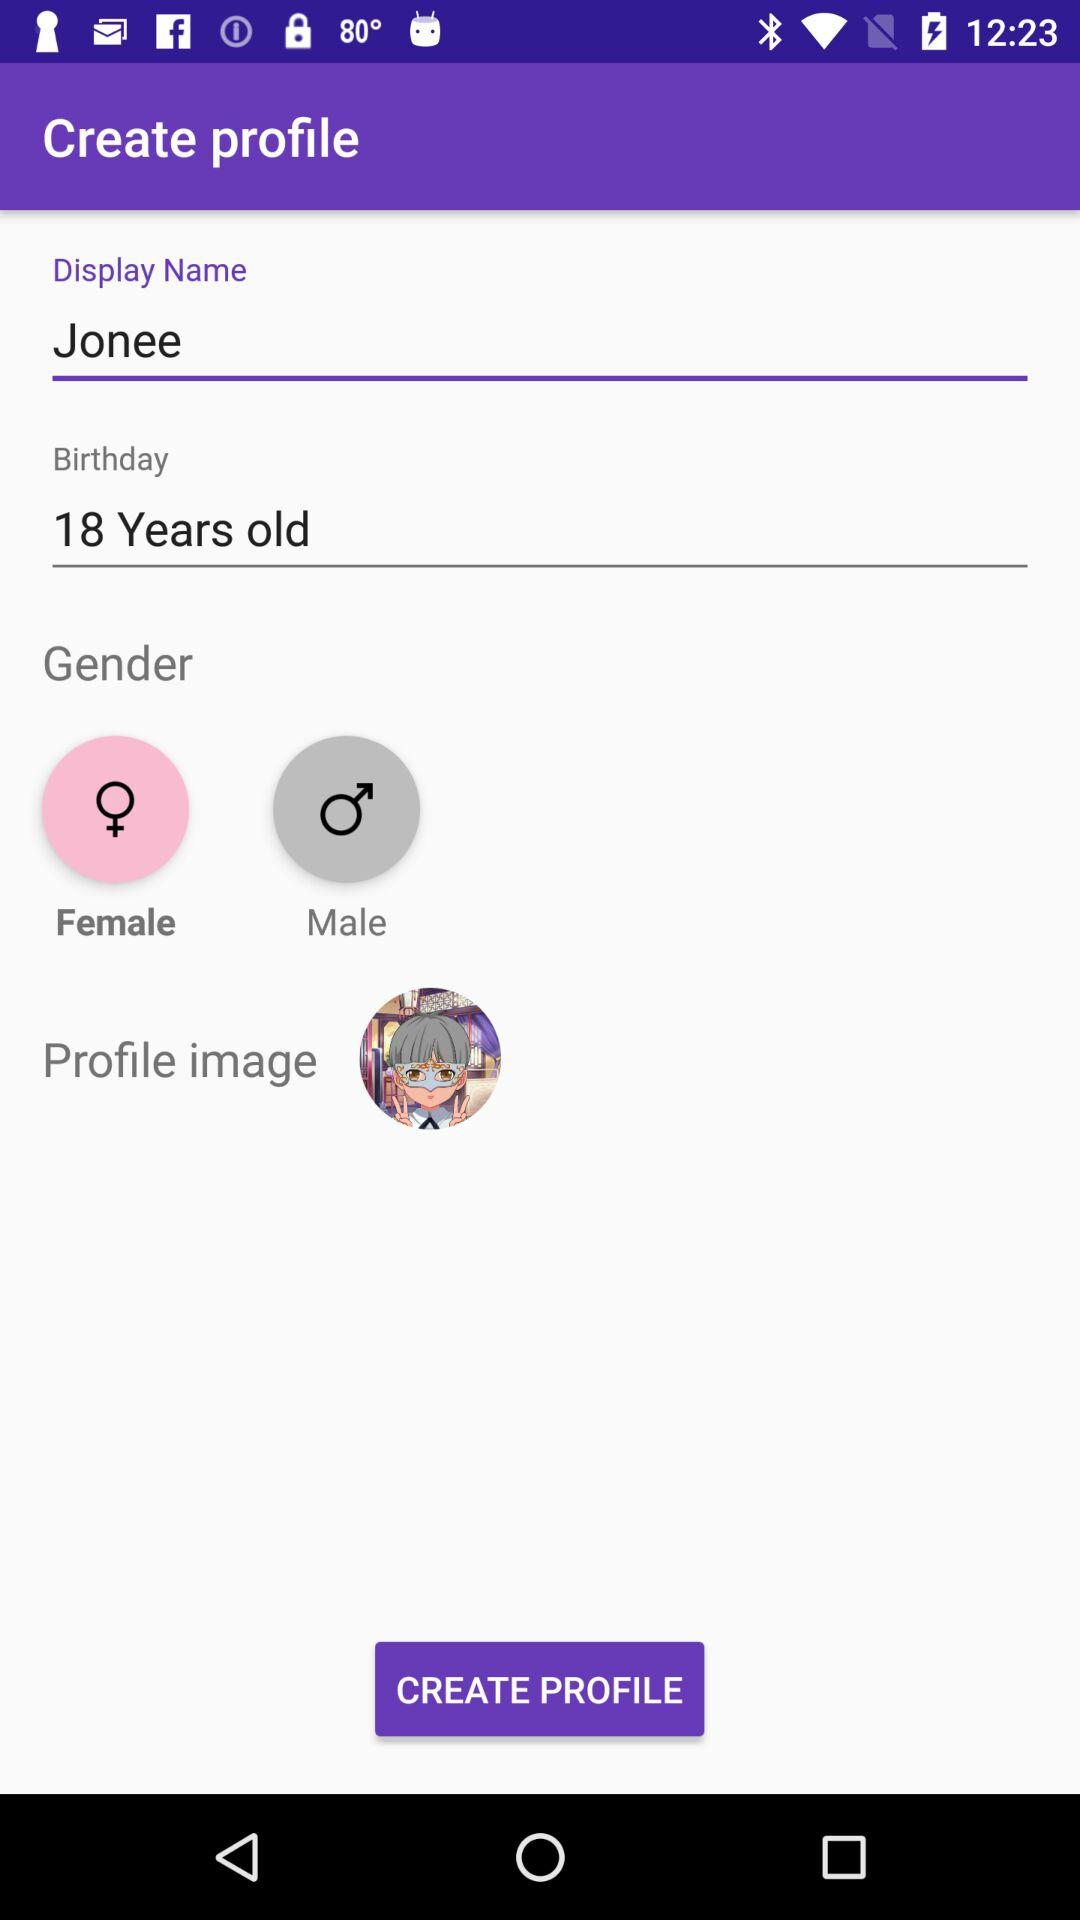What is the user name? The user name is Jonee. 